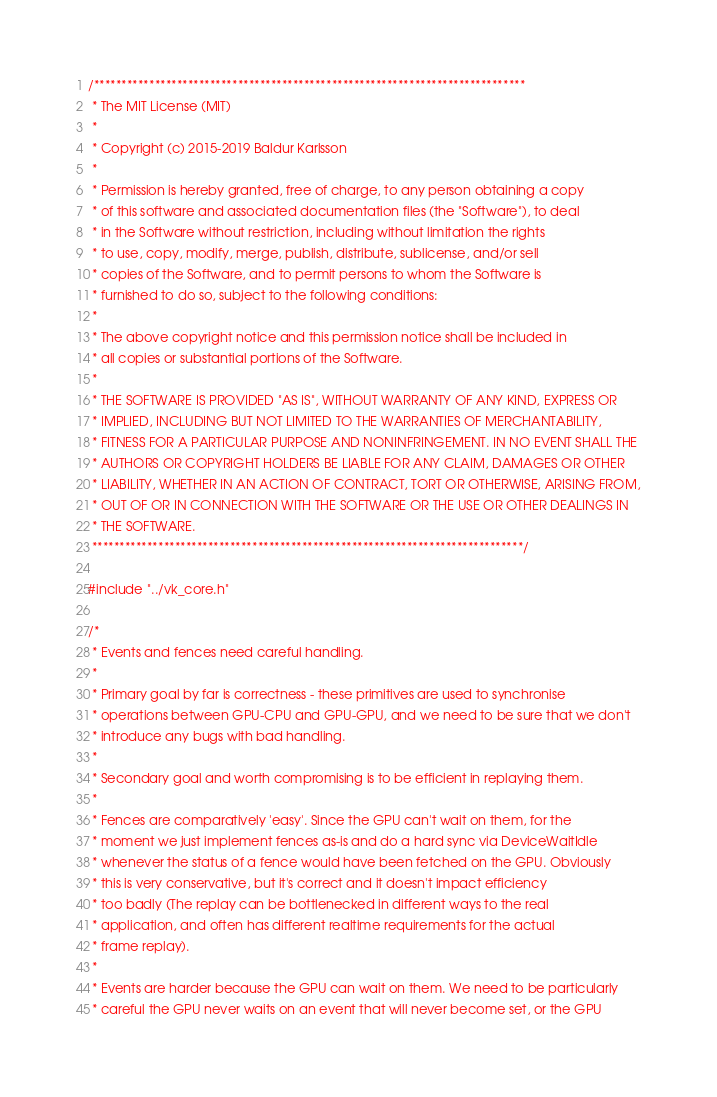<code> <loc_0><loc_0><loc_500><loc_500><_C++_>/******************************************************************************
 * The MIT License (MIT)
 *
 * Copyright (c) 2015-2019 Baldur Karlsson
 *
 * Permission is hereby granted, free of charge, to any person obtaining a copy
 * of this software and associated documentation files (the "Software"), to deal
 * in the Software without restriction, including without limitation the rights
 * to use, copy, modify, merge, publish, distribute, sublicense, and/or sell
 * copies of the Software, and to permit persons to whom the Software is
 * furnished to do so, subject to the following conditions:
 *
 * The above copyright notice and this permission notice shall be included in
 * all copies or substantial portions of the Software.
 *
 * THE SOFTWARE IS PROVIDED "AS IS", WITHOUT WARRANTY OF ANY KIND, EXPRESS OR
 * IMPLIED, INCLUDING BUT NOT LIMITED TO THE WARRANTIES OF MERCHANTABILITY,
 * FITNESS FOR A PARTICULAR PURPOSE AND NONINFRINGEMENT. IN NO EVENT SHALL THE
 * AUTHORS OR COPYRIGHT HOLDERS BE LIABLE FOR ANY CLAIM, DAMAGES OR OTHER
 * LIABILITY, WHETHER IN AN ACTION OF CONTRACT, TORT OR OTHERWISE, ARISING FROM,
 * OUT OF OR IN CONNECTION WITH THE SOFTWARE OR THE USE OR OTHER DEALINGS IN
 * THE SOFTWARE.
 ******************************************************************************/

#include "../vk_core.h"

/*
 * Events and fences need careful handling.
 *
 * Primary goal by far is correctness - these primitives are used to synchronise
 * operations between GPU-CPU and GPU-GPU, and we need to be sure that we don't
 * introduce any bugs with bad handling.
 *
 * Secondary goal and worth compromising is to be efficient in replaying them.
 *
 * Fences are comparatively 'easy'. Since the GPU can't wait on them, for the
 * moment we just implement fences as-is and do a hard sync via DeviceWaitIdle
 * whenever the status of a fence would have been fetched on the GPU. Obviously
 * this is very conservative, but it's correct and it doesn't impact efficiency
 * too badly (The replay can be bottlenecked in different ways to the real
 * application, and often has different realtime requirements for the actual
 * frame replay).
 *
 * Events are harder because the GPU can wait on them. We need to be particularly
 * careful the GPU never waits on an event that will never become set, or the GPU</code> 